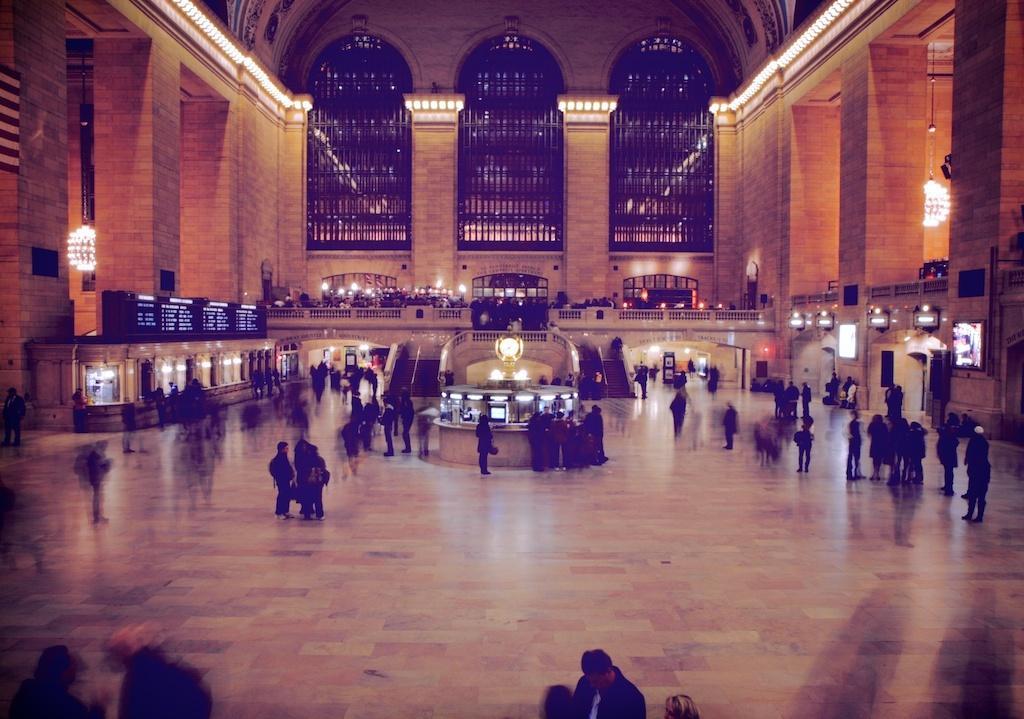Describe this image in one or two sentences. In the picture we can see an interior of the airport building and on the path we can see many people are walking and standing and to the left hand side we can see ticket counter and to the right hand side we can see a exists and in the background we can see a wall with steps and to the ceiling we can see lights which are decorated in line. 